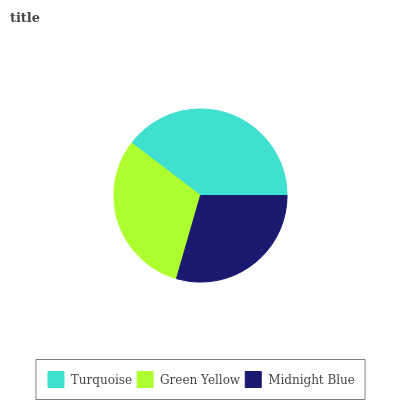Is Midnight Blue the minimum?
Answer yes or no. Yes. Is Turquoise the maximum?
Answer yes or no. Yes. Is Green Yellow the minimum?
Answer yes or no. No. Is Green Yellow the maximum?
Answer yes or no. No. Is Turquoise greater than Green Yellow?
Answer yes or no. Yes. Is Green Yellow less than Turquoise?
Answer yes or no. Yes. Is Green Yellow greater than Turquoise?
Answer yes or no. No. Is Turquoise less than Green Yellow?
Answer yes or no. No. Is Green Yellow the high median?
Answer yes or no. Yes. Is Green Yellow the low median?
Answer yes or no. Yes. Is Midnight Blue the high median?
Answer yes or no. No. Is Midnight Blue the low median?
Answer yes or no. No. 